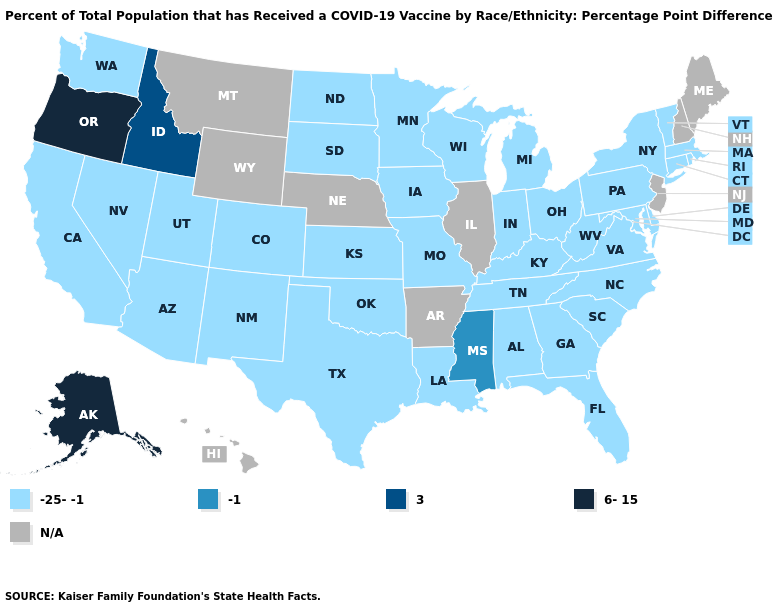What is the value of Vermont?
Give a very brief answer. -25--1. Does Mississippi have the lowest value in the USA?
Write a very short answer. No. What is the lowest value in the MidWest?
Answer briefly. -25--1. Name the states that have a value in the range 6-15?
Be succinct. Alaska, Oregon. Which states have the highest value in the USA?
Quick response, please. Alaska, Oregon. Which states have the highest value in the USA?
Short answer required. Alaska, Oregon. Name the states that have a value in the range N/A?
Write a very short answer. Arkansas, Hawaii, Illinois, Maine, Montana, Nebraska, New Hampshire, New Jersey, Wyoming. What is the value of Mississippi?
Short answer required. -1. What is the value of Wyoming?
Short answer required. N/A. What is the value of Idaho?
Keep it brief. 3. What is the value of Illinois?
Be succinct. N/A. Does Kentucky have the lowest value in the South?
Short answer required. Yes. 